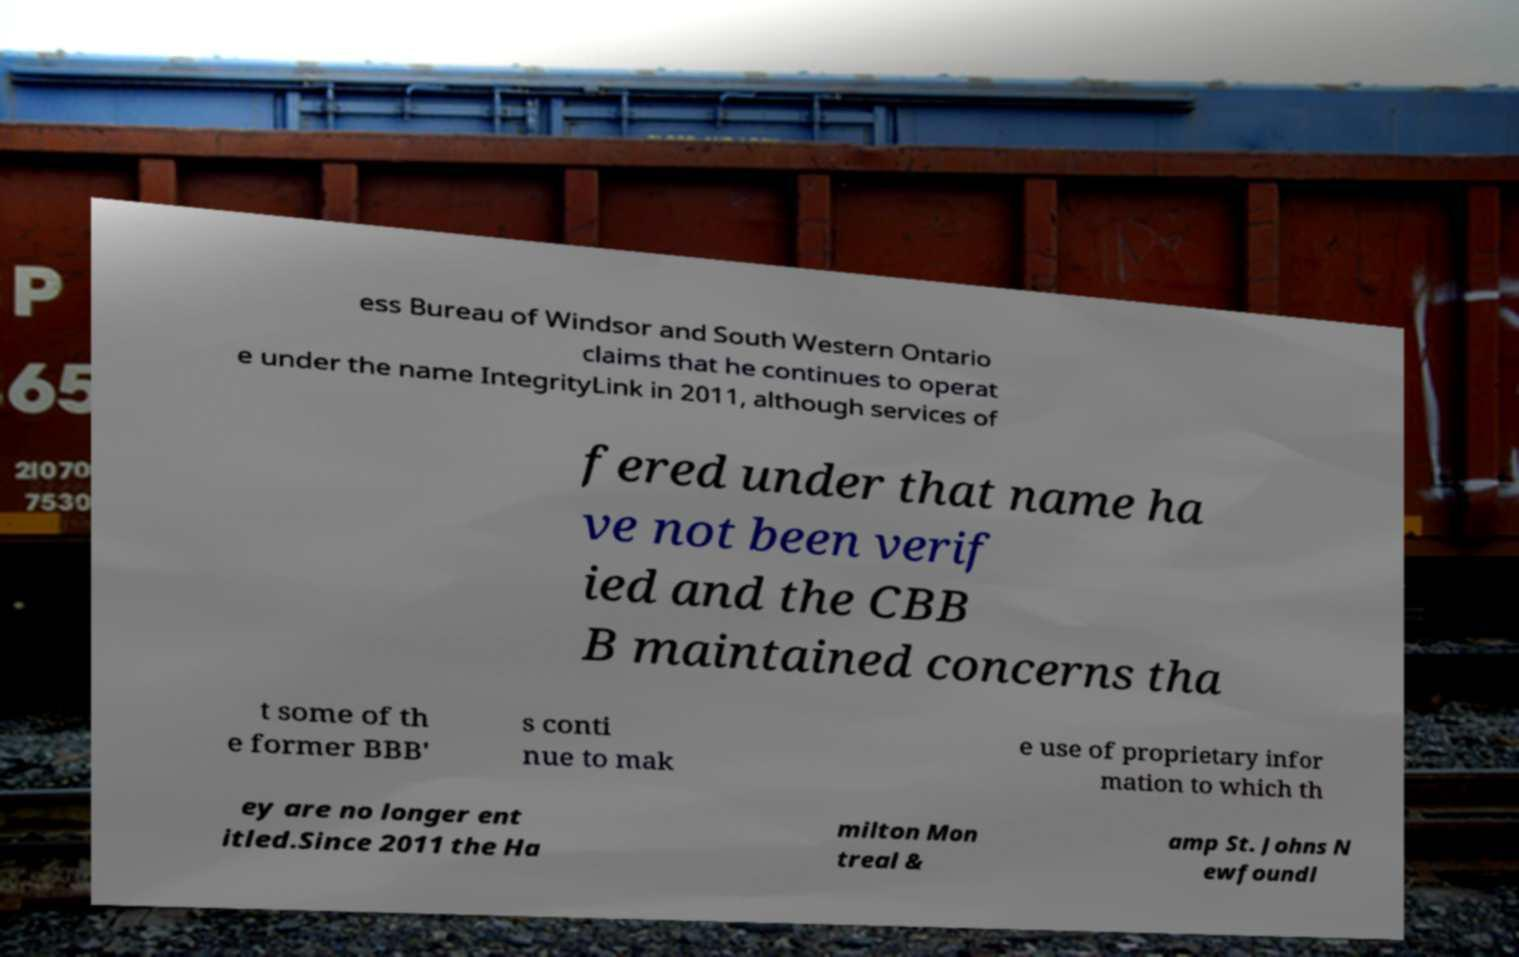I need the written content from this picture converted into text. Can you do that? ess Bureau of Windsor and South Western Ontario claims that he continues to operat e under the name IntegrityLink in 2011, although services of fered under that name ha ve not been verif ied and the CBB B maintained concerns tha t some of th e former BBB' s conti nue to mak e use of proprietary infor mation to which th ey are no longer ent itled.Since 2011 the Ha milton Mon treal & amp St. Johns N ewfoundl 